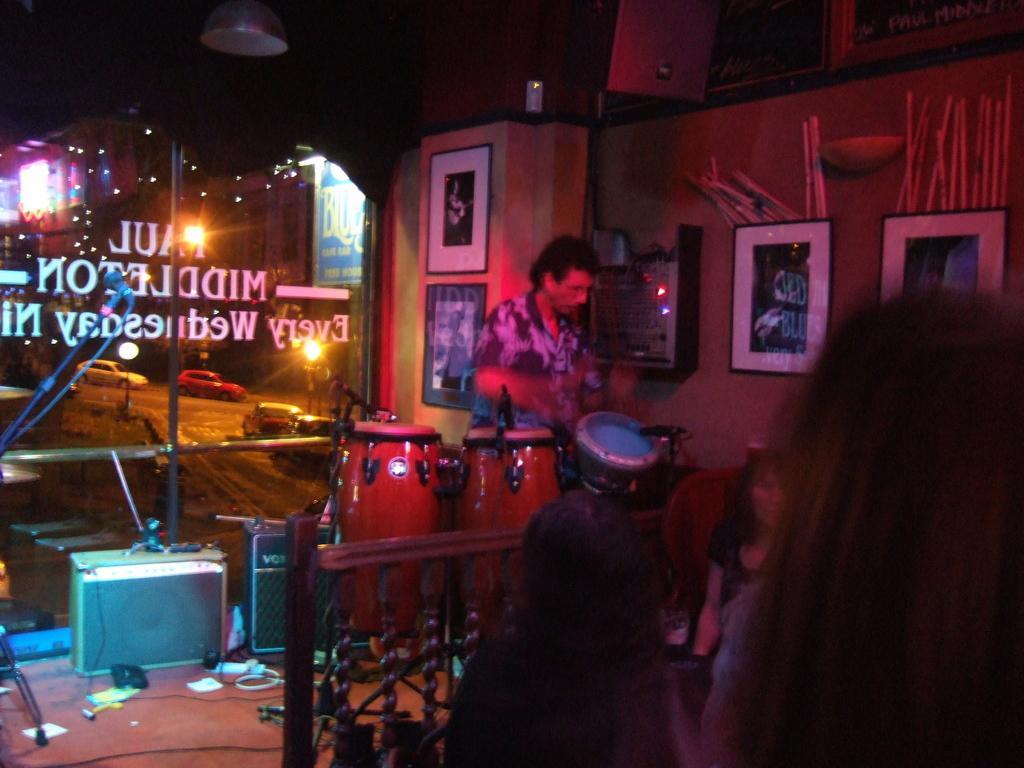Can you describe this image briefly? In the image there is a man standing in front of a musical instruments. On right side we can also see few people are sitting and few people are standing and we can also see photo frames on walls. On left side there is speakers and a glass,window,cars in background and a light. 